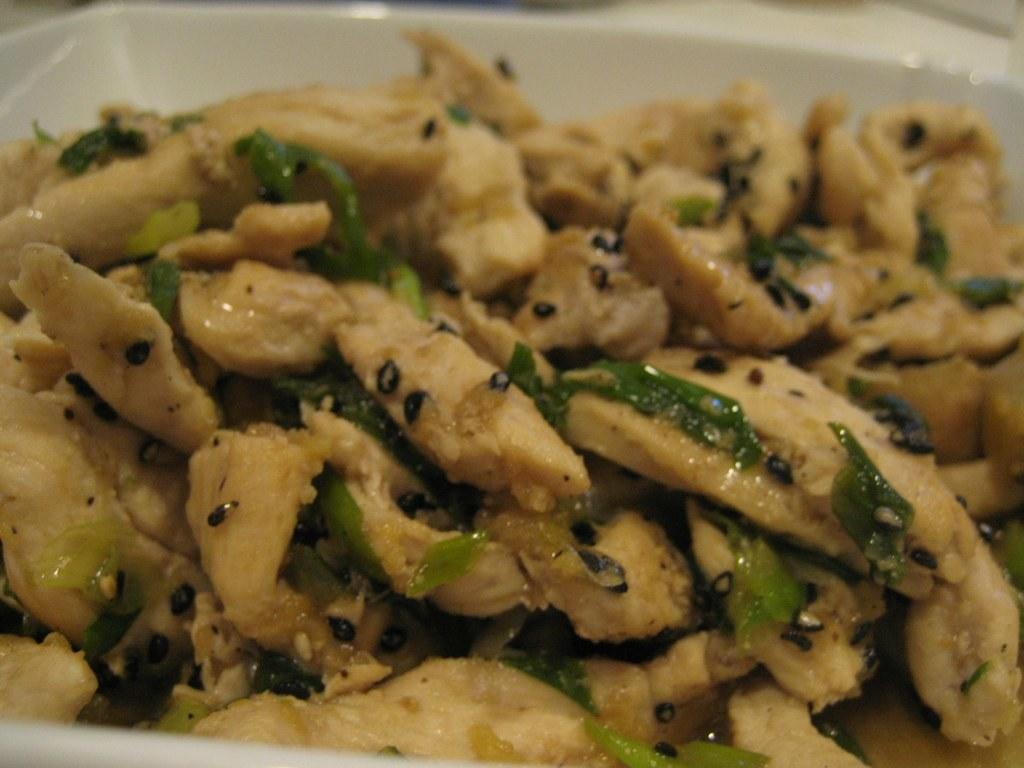What is in the bowl that is visible in the image? There is food in a bowl in the image. How many zephyrs can be seen sailing on the boats in the image? There are no zephyrs or boats present in the image; it only features a bowl of food. 